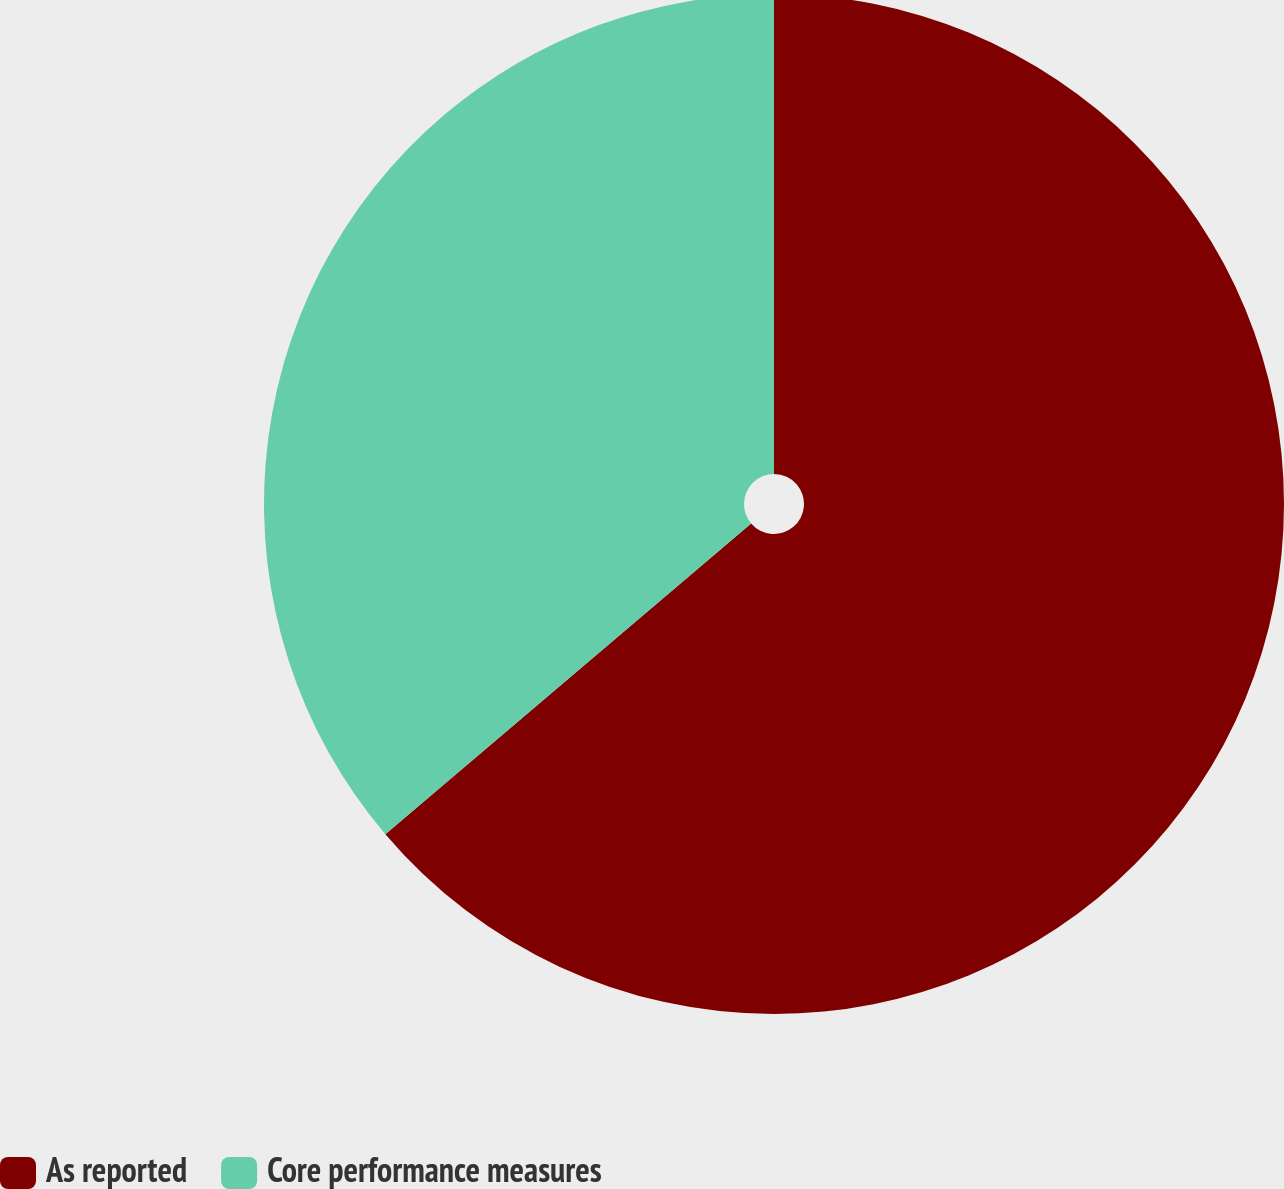<chart> <loc_0><loc_0><loc_500><loc_500><pie_chart><fcel>As reported<fcel>Core performance measures<nl><fcel>63.79%<fcel>36.21%<nl></chart> 